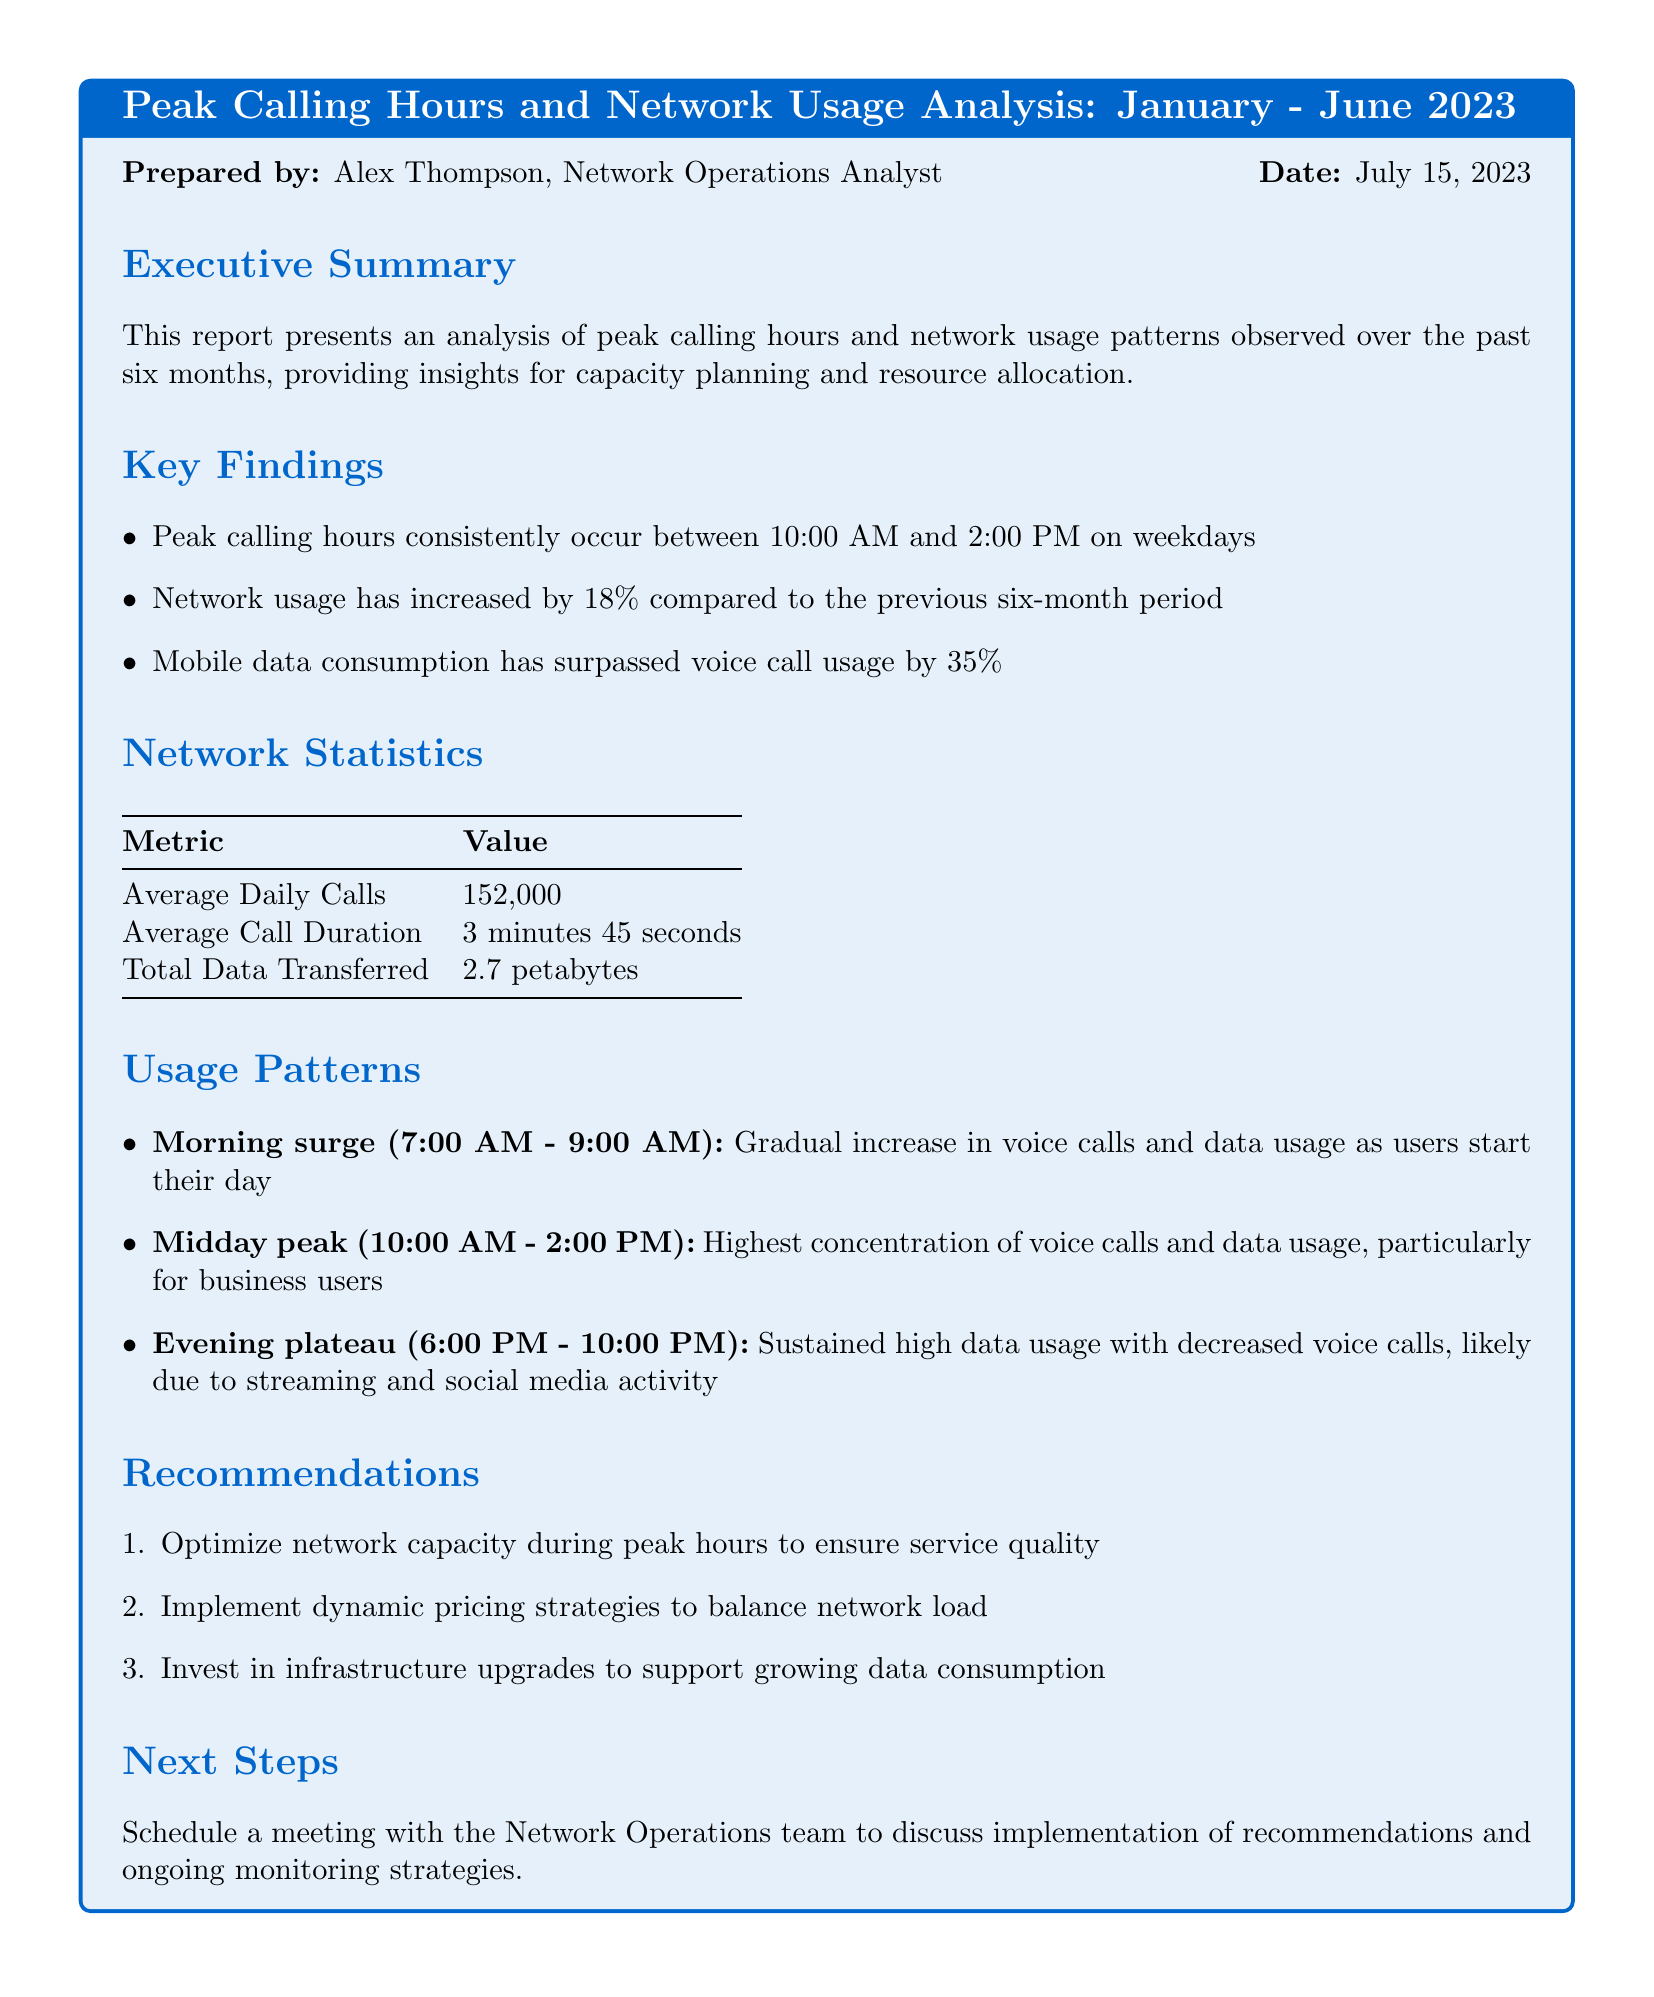What are the peak calling hours? The report states that peak calling hours consistently occur between 10:00 AM and 2:00 PM on weekdays.
Answer: 10:00 AM to 2:00 PM Who prepared the report? The document mentions the author of the report at the beginning.
Answer: Alex Thompson What is the total data transferred? The report includes a statistic indicating the total data transferred over the analyzed period.
Answer: 2.7 petabytes By what percentage has network usage increased? The key findings section provides a specific figure for the increase in network usage compared to the previous period.
Answer: 18% What is the average call duration? The statistics table includes a metric for the average duration of calls made.
Answer: 3 minutes 45 seconds During which times does the morning surge occur? The usage patterns section outlines the time frame for the morning surge in calls and data usage.
Answer: 7:00 AM - 9:00 AM What is the recommendation regarding network capacity? The recommendations section contains a specific suggestion about optimizing network capacity.
Answer: Optimize network capacity during peak hours How much has mobile data consumption surpassed voice call usage? The key findings section specifies the extent to which mobile data consumption has increased in comparison to voice calls.
Answer: 35% 